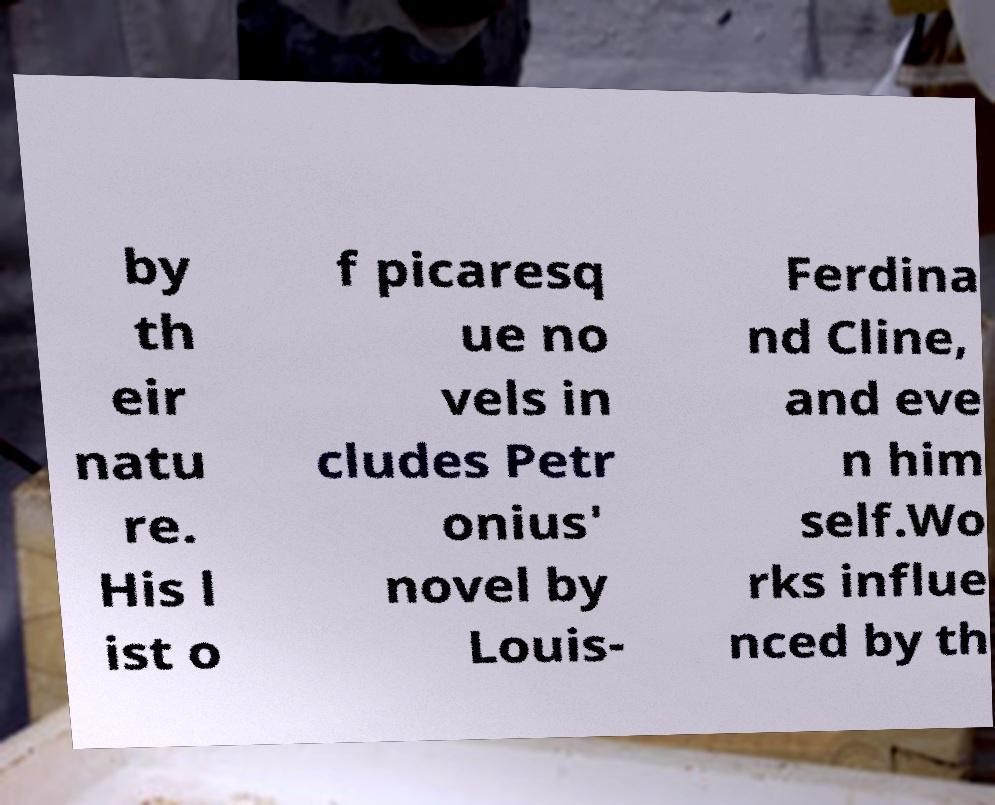Please read and relay the text visible in this image. What does it say? by th eir natu re. His l ist o f picaresq ue no vels in cludes Petr onius' novel by Louis- Ferdina nd Cline, and eve n him self.Wo rks influe nced by th 